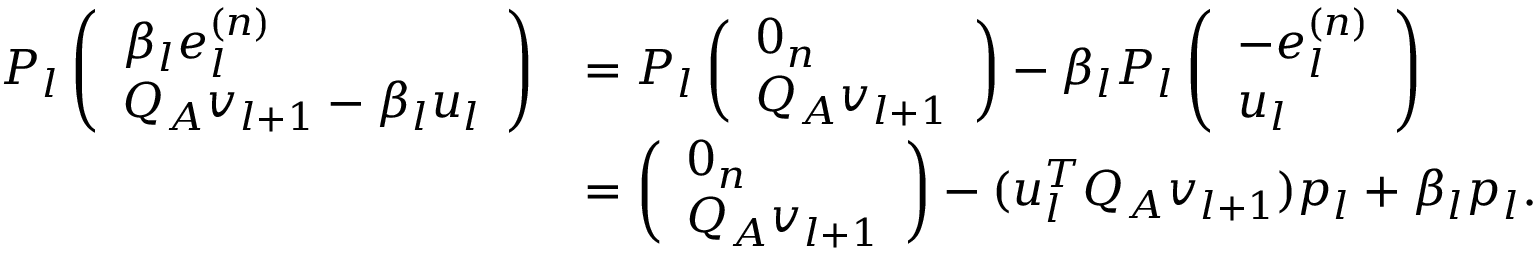<formula> <loc_0><loc_0><loc_500><loc_500>\begin{array} { r l } { P _ { l } \left ( \begin{array} { l } { \beta _ { l } e _ { l } ^ { ( n ) } } \\ { Q _ { A } v _ { l + 1 } - \beta _ { l } u _ { l } } \end{array} \right ) } & { = P _ { l } \left ( \begin{array} { l } { 0 _ { n } } \\ { Q _ { A } v _ { l + 1 } } \end{array} \right ) - \beta _ { l } P _ { l } \left ( \begin{array} { l } { - e _ { l } ^ { ( n ) } } \\ { u _ { l } } \end{array} \right ) } \\ & { = \left ( \begin{array} { l } { 0 _ { n } } \\ { Q _ { A } v _ { l + 1 } } \end{array} \right ) - ( u _ { l } ^ { T } Q _ { A } v _ { l + 1 } ) p _ { l } + \beta _ { l } p _ { l } . } \end{array}</formula> 